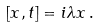<formula> <loc_0><loc_0><loc_500><loc_500>[ x , t ] = i \lambda x \, .</formula> 